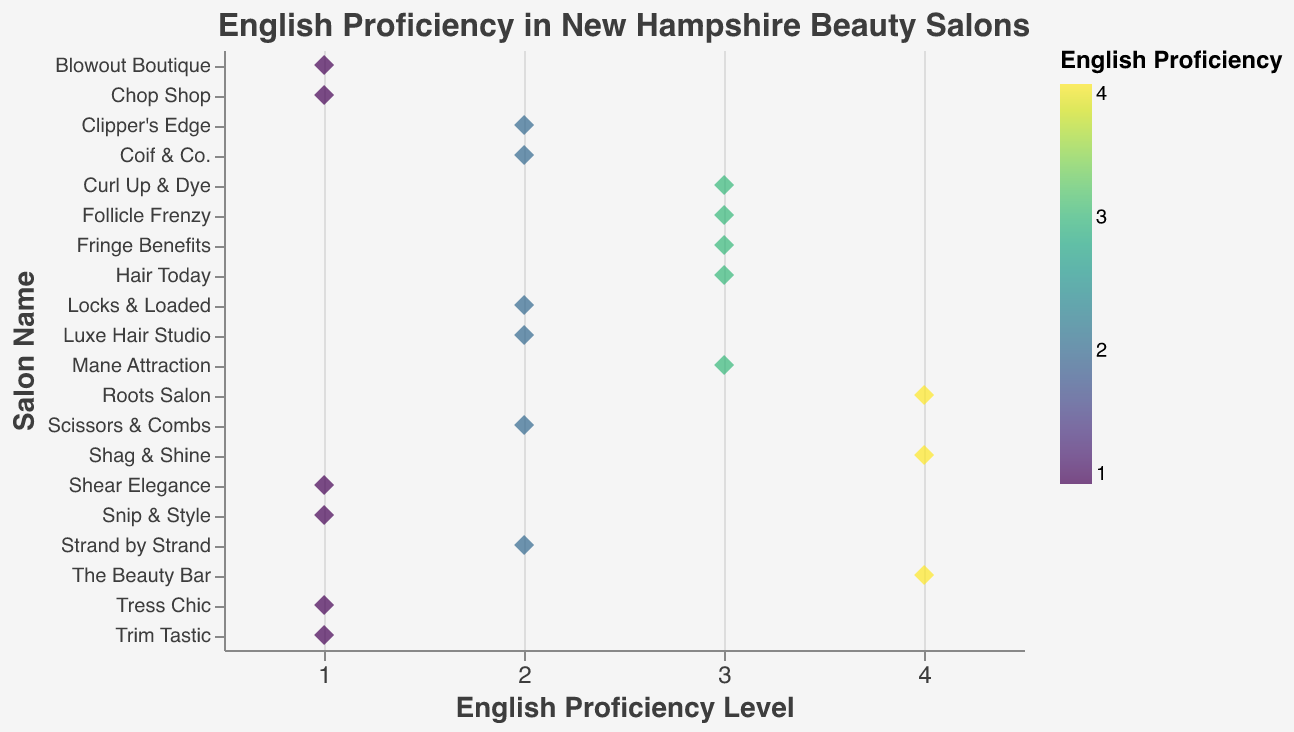How many salons have the highest English proficiency level (4)? We need to count the data points that have the English proficiency level of 4. They are "The Beauty Bar," "Roots Salon," and "Shag & Shine.”
Answer: 3 Which salons have the lowest English proficiency level (1)? We need to identify the data points with an English proficiency level of 1. They are "Shear Elegance," "Snip & Style," "Tress Chic," "Chop Shop," "Blowout Boutique," and "Trim Tastic."
Answer: 6 What's the average English proficiency level across all salons? To find the average, sum all the English proficiency levels and divide by the total number of salons. The sum is \(2 + 1 + 3 + 2 + 4 + 1 + 3 + 2 + 1 + 3 + 2 + 4 + 1 + 3 + 2 + 1 + 3 + 2 + 4 + 1 = 47\). There are 20 salons: \(47 \div 20 = 2.35\).
Answer: 2.35 How many salons have an English proficiency level of 3 or higher? We need to count the data points with an English proficiency level of 3 or 4. The salons at level 3 are "Curl Up & Dye," "Mane Attraction," "Hair Today," "Fringe Benefits," "Follicle Frenzy," and at level 4, we have "The Beauty Bar," "Roots Salon," "Shag & Shine."
Answer: 8 Which salon has an English proficiency level of 2 and starts with the letter "S"? From the data points with proficiency level 2, identify the salon name that starts with "S". It is "Scissors & Combs."
Answer: Scissors & Combs Is there any salon with the name starting with "L" having an English proficiency level of 3 or 4? Look at all salon names starting with "L" and check their proficiency levels. We have "Luxe Hair Studio" with proficiency level 2, no salons with proficiency 3 or 4.
Answer: No Which salons have the same English proficiency level of 2? Identify the data points with an English proficiency level of 2 and list their names. They are "Luxe Hair Studio," "Clipper's Edge," "Scissors & Combs," "Strand by Strand," "Locks & Loaded," "Coif & Co."
Answer: 6 Which salon has an English proficiency level of 3 and a name that involves a pun? Filter the salons with proficiency level 3 and look for names involving a pun. They are "Curl Up & Dye", "Hair Today," "Fringe Benefits," and "Follicle Frenzy."
Answer: 4 How many unique English proficiency levels are shown in the figure? Identify the distinct proficiency levels displayed in the figure. They are 1, 2, 3, and 4.
Answer: 4 